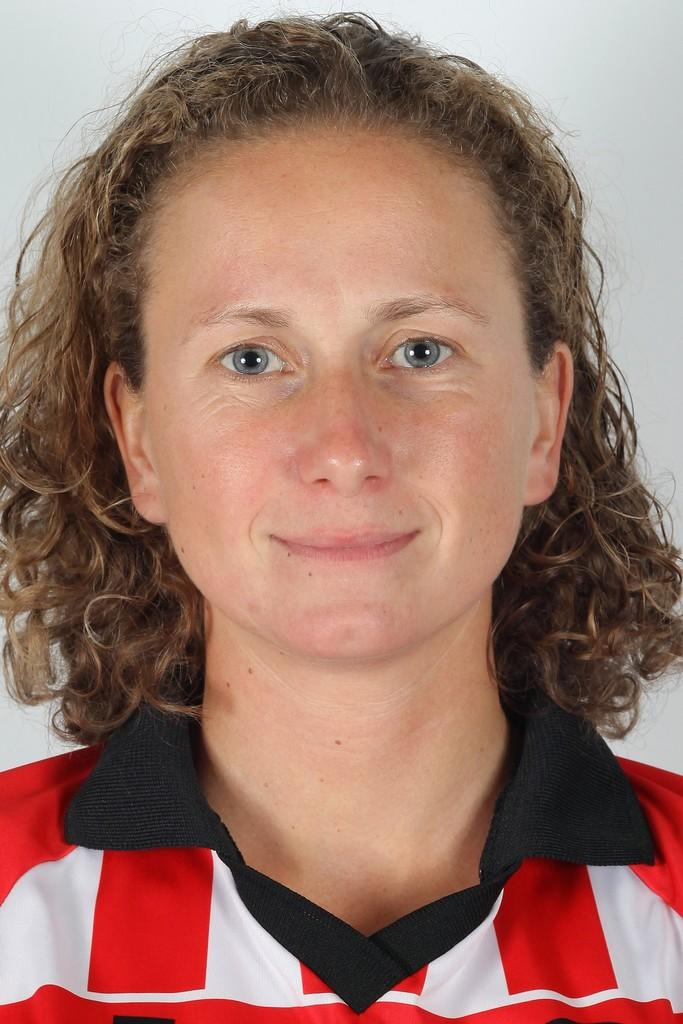What is the main subject of the image? The main subject of the image is a woman. What is the woman wearing in the image? The woman is wearing a red and white color dress. Can you see the woman biting into an apple in the image? There is no apple or any indication of the woman biting into anything in the image. Is the woman's nose visible in the image? The woman's nose is not specifically mentioned or focused on in the provided facts, but it can be assumed that her nose is visible as part of her face. 